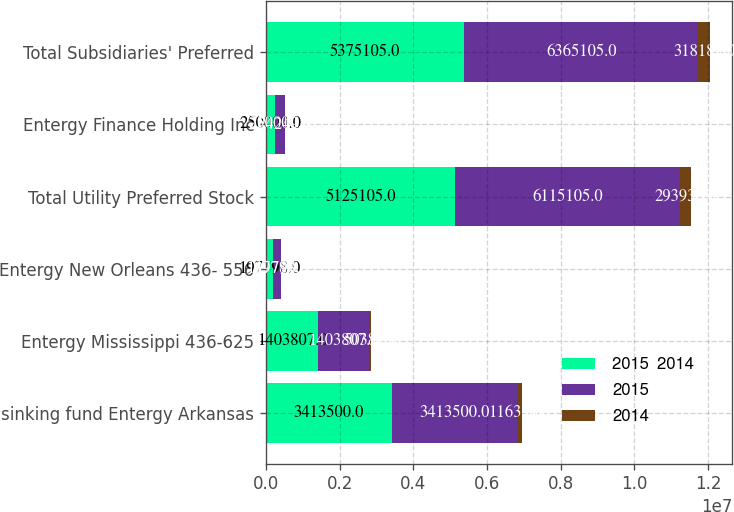Convert chart to OTSL. <chart><loc_0><loc_0><loc_500><loc_500><stacked_bar_chart><ecel><fcel>sinking fund Entergy Arkansas<fcel>Entergy Mississippi 436-625<fcel>Entergy New Orleans 436- 556<fcel>Total Utility Preferred Stock<fcel>Entergy Finance Holding Inc<fcel>Total Subsidiaries' Preferred<nl><fcel>2015  2014<fcel>3.4135e+06<fcel>1.40381e+06<fcel>197798<fcel>5.1251e+06<fcel>250000<fcel>5.3751e+06<nl><fcel>2015<fcel>3.4135e+06<fcel>1.40381e+06<fcel>197798<fcel>6.1151e+06<fcel>250000<fcel>6.3651e+06<nl><fcel>2014<fcel>116350<fcel>50381<fcel>19780<fcel>293936<fcel>24249<fcel>318185<nl></chart> 